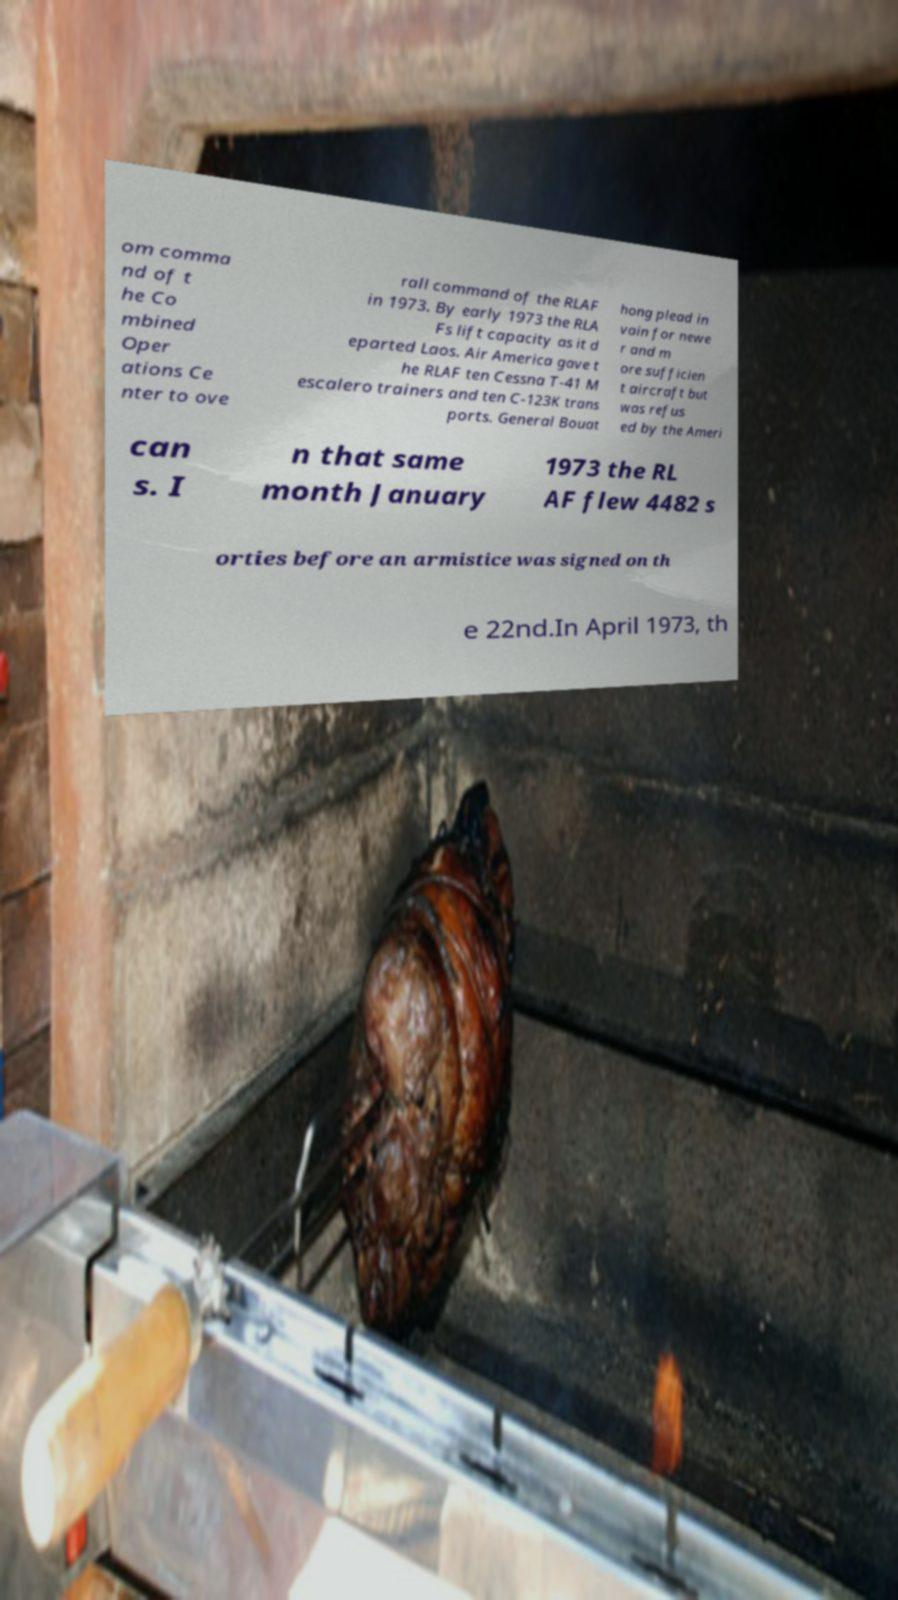Please read and relay the text visible in this image. What does it say? om comma nd of t he Co mbined Oper ations Ce nter to ove rall command of the RLAF in 1973. By early 1973 the RLA Fs lift capacity as it d eparted Laos. Air America gave t he RLAF ten Cessna T-41 M escalero trainers and ten C-123K trans ports. General Bouat hong plead in vain for newe r and m ore sufficien t aircraft but was refus ed by the Ameri can s. I n that same month January 1973 the RL AF flew 4482 s orties before an armistice was signed on th e 22nd.In April 1973, th 